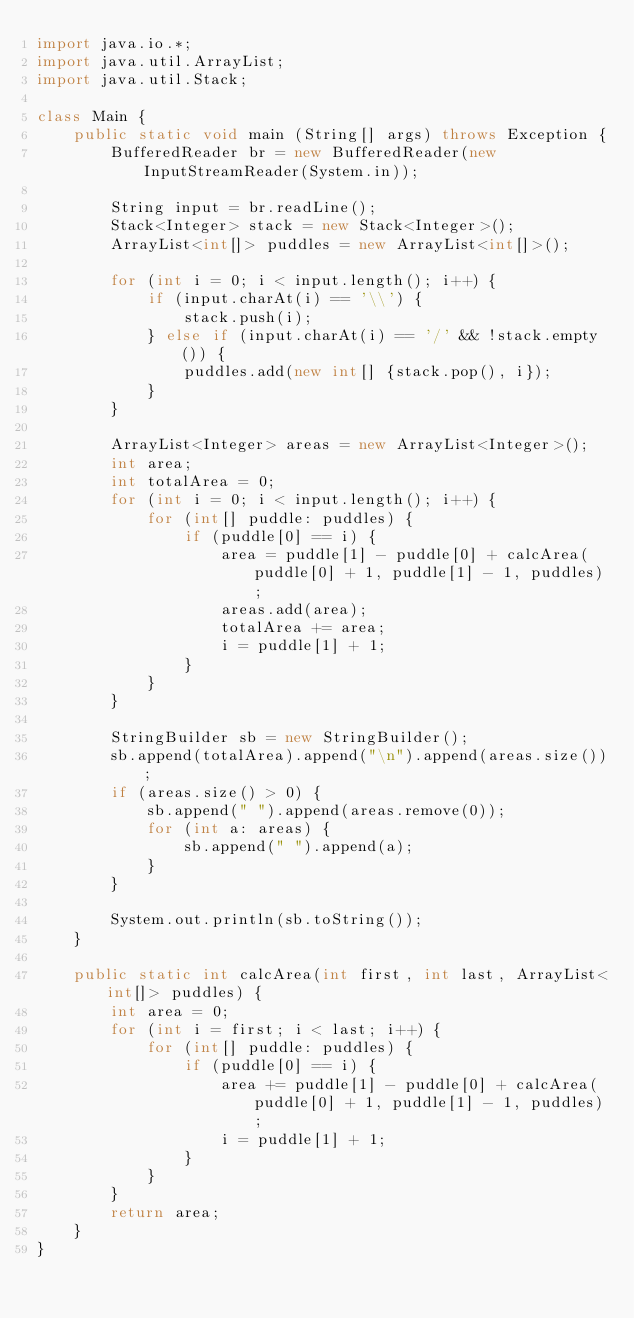<code> <loc_0><loc_0><loc_500><loc_500><_Java_>import java.io.*;
import java.util.ArrayList;
import java.util.Stack;

class Main {
    public static void main (String[] args) throws Exception {
        BufferedReader br = new BufferedReader(new InputStreamReader(System.in));
        
        String input = br.readLine();
        Stack<Integer> stack = new Stack<Integer>();
        ArrayList<int[]> puddles = new ArrayList<int[]>();

        for (int i = 0; i < input.length(); i++) {
            if (input.charAt(i) == '\\') {
                stack.push(i);
            } else if (input.charAt(i) == '/' && !stack.empty()) {
                puddles.add(new int[] {stack.pop(), i});
            }
        }

        ArrayList<Integer> areas = new ArrayList<Integer>();
        int area;
        int totalArea = 0;
        for (int i = 0; i < input.length(); i++) {
            for (int[] puddle: puddles) {
                if (puddle[0] == i) {
                    area = puddle[1] - puddle[0] + calcArea(puddle[0] + 1, puddle[1] - 1, puddles);
                    areas.add(area);
                    totalArea += area;
                    i = puddle[1] + 1;
                }
            }
        }

        StringBuilder sb = new StringBuilder();
        sb.append(totalArea).append("\n").append(areas.size());
        if (areas.size() > 0) {
            sb.append(" ").append(areas.remove(0));
            for (int a: areas) {
                sb.append(" ").append(a);
            }
        }

        System.out.println(sb.toString());
    }

    public static int calcArea(int first, int last, ArrayList<int[]> puddles) {
        int area = 0;
        for (int i = first; i < last; i++) {
            for (int[] puddle: puddles) {
                if (puddle[0] == i) {
                    area += puddle[1] - puddle[0] + calcArea(puddle[0] + 1, puddle[1] - 1, puddles);
                    i = puddle[1] + 1;
                }
            }
        }
        return area;
    }
}</code> 